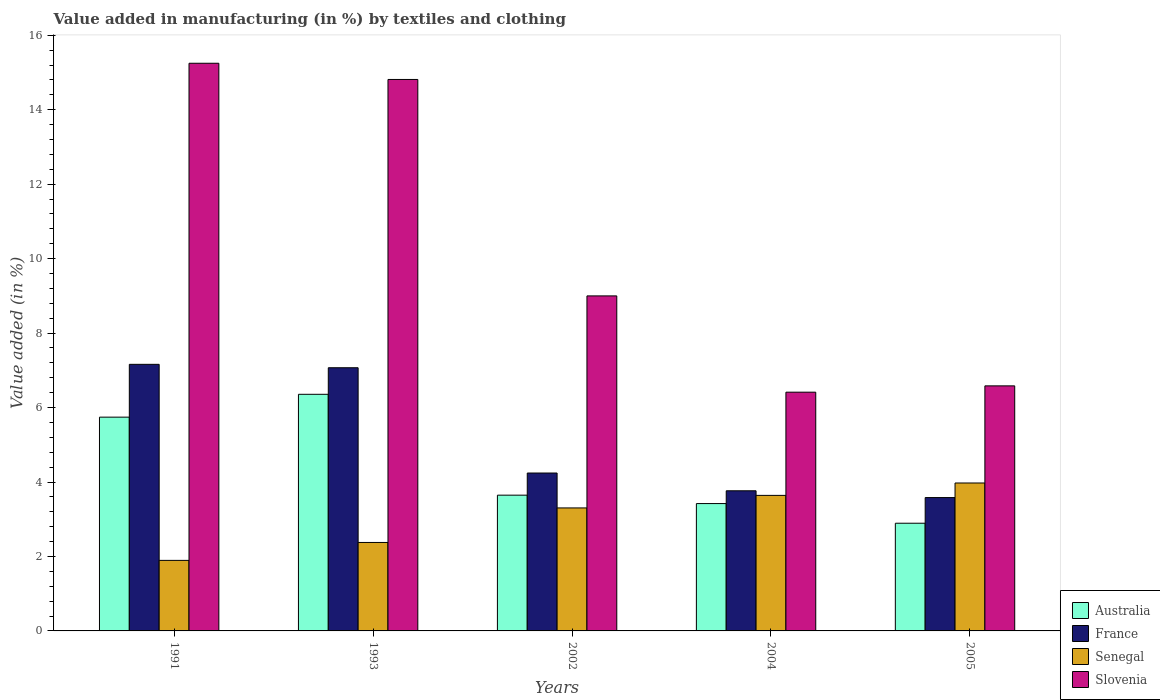Are the number of bars per tick equal to the number of legend labels?
Keep it short and to the point. Yes. Are the number of bars on each tick of the X-axis equal?
Offer a very short reply. Yes. What is the label of the 5th group of bars from the left?
Provide a succinct answer. 2005. In how many cases, is the number of bars for a given year not equal to the number of legend labels?
Give a very brief answer. 0. What is the percentage of value added in manufacturing by textiles and clothing in Senegal in 2004?
Ensure brevity in your answer.  3.64. Across all years, what is the maximum percentage of value added in manufacturing by textiles and clothing in Slovenia?
Ensure brevity in your answer.  15.25. Across all years, what is the minimum percentage of value added in manufacturing by textiles and clothing in Slovenia?
Provide a succinct answer. 6.41. In which year was the percentage of value added in manufacturing by textiles and clothing in Senegal maximum?
Provide a short and direct response. 2005. What is the total percentage of value added in manufacturing by textiles and clothing in Senegal in the graph?
Provide a short and direct response. 15.19. What is the difference between the percentage of value added in manufacturing by textiles and clothing in Senegal in 1991 and that in 1993?
Keep it short and to the point. -0.48. What is the difference between the percentage of value added in manufacturing by textiles and clothing in Slovenia in 1993 and the percentage of value added in manufacturing by textiles and clothing in Australia in 2005?
Your response must be concise. 11.92. What is the average percentage of value added in manufacturing by textiles and clothing in Australia per year?
Ensure brevity in your answer.  4.41. In the year 2004, what is the difference between the percentage of value added in manufacturing by textiles and clothing in France and percentage of value added in manufacturing by textiles and clothing in Slovenia?
Your response must be concise. -2.65. What is the ratio of the percentage of value added in manufacturing by textiles and clothing in Australia in 2004 to that in 2005?
Your response must be concise. 1.18. Is the difference between the percentage of value added in manufacturing by textiles and clothing in France in 1991 and 2002 greater than the difference between the percentage of value added in manufacturing by textiles and clothing in Slovenia in 1991 and 2002?
Ensure brevity in your answer.  No. What is the difference between the highest and the second highest percentage of value added in manufacturing by textiles and clothing in France?
Offer a very short reply. 0.09. What is the difference between the highest and the lowest percentage of value added in manufacturing by textiles and clothing in Senegal?
Your answer should be compact. 2.08. Is it the case that in every year, the sum of the percentage of value added in manufacturing by textiles and clothing in Slovenia and percentage of value added in manufacturing by textiles and clothing in France is greater than the sum of percentage of value added in manufacturing by textiles and clothing in Senegal and percentage of value added in manufacturing by textiles and clothing in Australia?
Provide a short and direct response. No. What does the 1st bar from the right in 1993 represents?
Make the answer very short. Slovenia. How many bars are there?
Make the answer very short. 20. Are the values on the major ticks of Y-axis written in scientific E-notation?
Your answer should be very brief. No. Does the graph contain any zero values?
Your response must be concise. No. What is the title of the graph?
Provide a short and direct response. Value added in manufacturing (in %) by textiles and clothing. What is the label or title of the Y-axis?
Provide a short and direct response. Value added (in %). What is the Value added (in %) of Australia in 1991?
Make the answer very short. 5.74. What is the Value added (in %) of France in 1991?
Ensure brevity in your answer.  7.16. What is the Value added (in %) of Senegal in 1991?
Offer a very short reply. 1.89. What is the Value added (in %) of Slovenia in 1991?
Your answer should be very brief. 15.25. What is the Value added (in %) in Australia in 1993?
Offer a terse response. 6.36. What is the Value added (in %) of France in 1993?
Keep it short and to the point. 7.07. What is the Value added (in %) in Senegal in 1993?
Offer a terse response. 2.38. What is the Value added (in %) of Slovenia in 1993?
Provide a short and direct response. 14.81. What is the Value added (in %) in Australia in 2002?
Ensure brevity in your answer.  3.65. What is the Value added (in %) of France in 2002?
Keep it short and to the point. 4.24. What is the Value added (in %) in Senegal in 2002?
Your response must be concise. 3.3. What is the Value added (in %) in Slovenia in 2002?
Offer a terse response. 9. What is the Value added (in %) of Australia in 2004?
Provide a succinct answer. 3.42. What is the Value added (in %) in France in 2004?
Give a very brief answer. 3.76. What is the Value added (in %) in Senegal in 2004?
Your answer should be compact. 3.64. What is the Value added (in %) in Slovenia in 2004?
Your response must be concise. 6.41. What is the Value added (in %) in Australia in 2005?
Give a very brief answer. 2.89. What is the Value added (in %) in France in 2005?
Make the answer very short. 3.58. What is the Value added (in %) of Senegal in 2005?
Offer a very short reply. 3.97. What is the Value added (in %) in Slovenia in 2005?
Give a very brief answer. 6.58. Across all years, what is the maximum Value added (in %) of Australia?
Ensure brevity in your answer.  6.36. Across all years, what is the maximum Value added (in %) in France?
Your answer should be compact. 7.16. Across all years, what is the maximum Value added (in %) in Senegal?
Your answer should be compact. 3.97. Across all years, what is the maximum Value added (in %) in Slovenia?
Your answer should be compact. 15.25. Across all years, what is the minimum Value added (in %) in Australia?
Give a very brief answer. 2.89. Across all years, what is the minimum Value added (in %) of France?
Offer a very short reply. 3.58. Across all years, what is the minimum Value added (in %) in Senegal?
Provide a succinct answer. 1.89. Across all years, what is the minimum Value added (in %) of Slovenia?
Offer a terse response. 6.41. What is the total Value added (in %) of Australia in the graph?
Offer a very short reply. 22.06. What is the total Value added (in %) in France in the graph?
Offer a very short reply. 25.82. What is the total Value added (in %) in Senegal in the graph?
Your answer should be very brief. 15.19. What is the total Value added (in %) of Slovenia in the graph?
Offer a very short reply. 52.06. What is the difference between the Value added (in %) of Australia in 1991 and that in 1993?
Make the answer very short. -0.61. What is the difference between the Value added (in %) in France in 1991 and that in 1993?
Your answer should be very brief. 0.09. What is the difference between the Value added (in %) of Senegal in 1991 and that in 1993?
Give a very brief answer. -0.48. What is the difference between the Value added (in %) of Slovenia in 1991 and that in 1993?
Your answer should be compact. 0.44. What is the difference between the Value added (in %) of Australia in 1991 and that in 2002?
Your answer should be compact. 2.1. What is the difference between the Value added (in %) in France in 1991 and that in 2002?
Offer a terse response. 2.92. What is the difference between the Value added (in %) in Senegal in 1991 and that in 2002?
Offer a terse response. -1.41. What is the difference between the Value added (in %) in Slovenia in 1991 and that in 2002?
Make the answer very short. 6.25. What is the difference between the Value added (in %) of Australia in 1991 and that in 2004?
Offer a very short reply. 2.32. What is the difference between the Value added (in %) of France in 1991 and that in 2004?
Ensure brevity in your answer.  3.4. What is the difference between the Value added (in %) of Senegal in 1991 and that in 2004?
Keep it short and to the point. -1.75. What is the difference between the Value added (in %) of Slovenia in 1991 and that in 2004?
Keep it short and to the point. 8.84. What is the difference between the Value added (in %) in Australia in 1991 and that in 2005?
Provide a short and direct response. 2.85. What is the difference between the Value added (in %) of France in 1991 and that in 2005?
Keep it short and to the point. 3.58. What is the difference between the Value added (in %) in Senegal in 1991 and that in 2005?
Offer a very short reply. -2.08. What is the difference between the Value added (in %) in Slovenia in 1991 and that in 2005?
Ensure brevity in your answer.  8.67. What is the difference between the Value added (in %) of Australia in 1993 and that in 2002?
Your answer should be very brief. 2.71. What is the difference between the Value added (in %) in France in 1993 and that in 2002?
Keep it short and to the point. 2.83. What is the difference between the Value added (in %) of Senegal in 1993 and that in 2002?
Provide a short and direct response. -0.93. What is the difference between the Value added (in %) in Slovenia in 1993 and that in 2002?
Give a very brief answer. 5.81. What is the difference between the Value added (in %) of Australia in 1993 and that in 2004?
Offer a terse response. 2.94. What is the difference between the Value added (in %) in France in 1993 and that in 2004?
Provide a succinct answer. 3.31. What is the difference between the Value added (in %) in Senegal in 1993 and that in 2004?
Give a very brief answer. -1.26. What is the difference between the Value added (in %) in Slovenia in 1993 and that in 2004?
Offer a very short reply. 8.4. What is the difference between the Value added (in %) in Australia in 1993 and that in 2005?
Provide a short and direct response. 3.46. What is the difference between the Value added (in %) in France in 1993 and that in 2005?
Ensure brevity in your answer.  3.49. What is the difference between the Value added (in %) of Senegal in 1993 and that in 2005?
Provide a short and direct response. -1.6. What is the difference between the Value added (in %) of Slovenia in 1993 and that in 2005?
Make the answer very short. 8.23. What is the difference between the Value added (in %) of Australia in 2002 and that in 2004?
Provide a succinct answer. 0.23. What is the difference between the Value added (in %) of France in 2002 and that in 2004?
Provide a succinct answer. 0.48. What is the difference between the Value added (in %) of Senegal in 2002 and that in 2004?
Keep it short and to the point. -0.34. What is the difference between the Value added (in %) in Slovenia in 2002 and that in 2004?
Offer a terse response. 2.59. What is the difference between the Value added (in %) of Australia in 2002 and that in 2005?
Your answer should be very brief. 0.75. What is the difference between the Value added (in %) in France in 2002 and that in 2005?
Offer a terse response. 0.66. What is the difference between the Value added (in %) of Senegal in 2002 and that in 2005?
Offer a very short reply. -0.67. What is the difference between the Value added (in %) in Slovenia in 2002 and that in 2005?
Provide a short and direct response. 2.42. What is the difference between the Value added (in %) of Australia in 2004 and that in 2005?
Make the answer very short. 0.53. What is the difference between the Value added (in %) in France in 2004 and that in 2005?
Ensure brevity in your answer.  0.18. What is the difference between the Value added (in %) in Senegal in 2004 and that in 2005?
Keep it short and to the point. -0.33. What is the difference between the Value added (in %) in Slovenia in 2004 and that in 2005?
Your answer should be compact. -0.17. What is the difference between the Value added (in %) in Australia in 1991 and the Value added (in %) in France in 1993?
Keep it short and to the point. -1.33. What is the difference between the Value added (in %) of Australia in 1991 and the Value added (in %) of Senegal in 1993?
Your answer should be compact. 3.37. What is the difference between the Value added (in %) in Australia in 1991 and the Value added (in %) in Slovenia in 1993?
Your answer should be very brief. -9.07. What is the difference between the Value added (in %) of France in 1991 and the Value added (in %) of Senegal in 1993?
Ensure brevity in your answer.  4.78. What is the difference between the Value added (in %) of France in 1991 and the Value added (in %) of Slovenia in 1993?
Give a very brief answer. -7.65. What is the difference between the Value added (in %) in Senegal in 1991 and the Value added (in %) in Slovenia in 1993?
Keep it short and to the point. -12.92. What is the difference between the Value added (in %) in Australia in 1991 and the Value added (in %) in France in 2002?
Your response must be concise. 1.5. What is the difference between the Value added (in %) in Australia in 1991 and the Value added (in %) in Senegal in 2002?
Make the answer very short. 2.44. What is the difference between the Value added (in %) of Australia in 1991 and the Value added (in %) of Slovenia in 2002?
Provide a short and direct response. -3.26. What is the difference between the Value added (in %) of France in 1991 and the Value added (in %) of Senegal in 2002?
Provide a succinct answer. 3.86. What is the difference between the Value added (in %) in France in 1991 and the Value added (in %) in Slovenia in 2002?
Your answer should be compact. -1.84. What is the difference between the Value added (in %) of Senegal in 1991 and the Value added (in %) of Slovenia in 2002?
Ensure brevity in your answer.  -7.1. What is the difference between the Value added (in %) of Australia in 1991 and the Value added (in %) of France in 2004?
Provide a short and direct response. 1.98. What is the difference between the Value added (in %) of Australia in 1991 and the Value added (in %) of Senegal in 2004?
Offer a very short reply. 2.1. What is the difference between the Value added (in %) in Australia in 1991 and the Value added (in %) in Slovenia in 2004?
Offer a terse response. -0.67. What is the difference between the Value added (in %) of France in 1991 and the Value added (in %) of Senegal in 2004?
Your answer should be very brief. 3.52. What is the difference between the Value added (in %) of France in 1991 and the Value added (in %) of Slovenia in 2004?
Your answer should be compact. 0.75. What is the difference between the Value added (in %) in Senegal in 1991 and the Value added (in %) in Slovenia in 2004?
Keep it short and to the point. -4.52. What is the difference between the Value added (in %) in Australia in 1991 and the Value added (in %) in France in 2005?
Your response must be concise. 2.16. What is the difference between the Value added (in %) of Australia in 1991 and the Value added (in %) of Senegal in 2005?
Provide a short and direct response. 1.77. What is the difference between the Value added (in %) of Australia in 1991 and the Value added (in %) of Slovenia in 2005?
Offer a very short reply. -0.84. What is the difference between the Value added (in %) of France in 1991 and the Value added (in %) of Senegal in 2005?
Your response must be concise. 3.19. What is the difference between the Value added (in %) in France in 1991 and the Value added (in %) in Slovenia in 2005?
Your response must be concise. 0.58. What is the difference between the Value added (in %) in Senegal in 1991 and the Value added (in %) in Slovenia in 2005?
Provide a short and direct response. -4.69. What is the difference between the Value added (in %) of Australia in 1993 and the Value added (in %) of France in 2002?
Your answer should be very brief. 2.11. What is the difference between the Value added (in %) in Australia in 1993 and the Value added (in %) in Senegal in 2002?
Provide a succinct answer. 3.05. What is the difference between the Value added (in %) of Australia in 1993 and the Value added (in %) of Slovenia in 2002?
Give a very brief answer. -2.64. What is the difference between the Value added (in %) of France in 1993 and the Value added (in %) of Senegal in 2002?
Ensure brevity in your answer.  3.77. What is the difference between the Value added (in %) of France in 1993 and the Value added (in %) of Slovenia in 2002?
Make the answer very short. -1.93. What is the difference between the Value added (in %) of Senegal in 1993 and the Value added (in %) of Slovenia in 2002?
Your response must be concise. -6.62. What is the difference between the Value added (in %) of Australia in 1993 and the Value added (in %) of France in 2004?
Ensure brevity in your answer.  2.59. What is the difference between the Value added (in %) in Australia in 1993 and the Value added (in %) in Senegal in 2004?
Offer a very short reply. 2.71. What is the difference between the Value added (in %) in Australia in 1993 and the Value added (in %) in Slovenia in 2004?
Give a very brief answer. -0.06. What is the difference between the Value added (in %) of France in 1993 and the Value added (in %) of Senegal in 2004?
Offer a terse response. 3.43. What is the difference between the Value added (in %) in France in 1993 and the Value added (in %) in Slovenia in 2004?
Your response must be concise. 0.66. What is the difference between the Value added (in %) in Senegal in 1993 and the Value added (in %) in Slovenia in 2004?
Provide a succinct answer. -4.04. What is the difference between the Value added (in %) in Australia in 1993 and the Value added (in %) in France in 2005?
Offer a terse response. 2.77. What is the difference between the Value added (in %) in Australia in 1993 and the Value added (in %) in Senegal in 2005?
Keep it short and to the point. 2.38. What is the difference between the Value added (in %) of Australia in 1993 and the Value added (in %) of Slovenia in 2005?
Provide a succinct answer. -0.23. What is the difference between the Value added (in %) in France in 1993 and the Value added (in %) in Senegal in 2005?
Your answer should be very brief. 3.1. What is the difference between the Value added (in %) in France in 1993 and the Value added (in %) in Slovenia in 2005?
Ensure brevity in your answer.  0.49. What is the difference between the Value added (in %) in Senegal in 1993 and the Value added (in %) in Slovenia in 2005?
Keep it short and to the point. -4.21. What is the difference between the Value added (in %) in Australia in 2002 and the Value added (in %) in France in 2004?
Offer a terse response. -0.12. What is the difference between the Value added (in %) of Australia in 2002 and the Value added (in %) of Senegal in 2004?
Offer a very short reply. 0.01. What is the difference between the Value added (in %) of Australia in 2002 and the Value added (in %) of Slovenia in 2004?
Ensure brevity in your answer.  -2.77. What is the difference between the Value added (in %) of France in 2002 and the Value added (in %) of Senegal in 2004?
Offer a very short reply. 0.6. What is the difference between the Value added (in %) in France in 2002 and the Value added (in %) in Slovenia in 2004?
Give a very brief answer. -2.17. What is the difference between the Value added (in %) in Senegal in 2002 and the Value added (in %) in Slovenia in 2004?
Give a very brief answer. -3.11. What is the difference between the Value added (in %) in Australia in 2002 and the Value added (in %) in France in 2005?
Offer a very short reply. 0.06. What is the difference between the Value added (in %) of Australia in 2002 and the Value added (in %) of Senegal in 2005?
Provide a short and direct response. -0.33. What is the difference between the Value added (in %) of Australia in 2002 and the Value added (in %) of Slovenia in 2005?
Ensure brevity in your answer.  -2.94. What is the difference between the Value added (in %) in France in 2002 and the Value added (in %) in Senegal in 2005?
Provide a succinct answer. 0.27. What is the difference between the Value added (in %) in France in 2002 and the Value added (in %) in Slovenia in 2005?
Your answer should be compact. -2.34. What is the difference between the Value added (in %) of Senegal in 2002 and the Value added (in %) of Slovenia in 2005?
Your answer should be very brief. -3.28. What is the difference between the Value added (in %) of Australia in 2004 and the Value added (in %) of France in 2005?
Offer a terse response. -0.16. What is the difference between the Value added (in %) of Australia in 2004 and the Value added (in %) of Senegal in 2005?
Make the answer very short. -0.55. What is the difference between the Value added (in %) in Australia in 2004 and the Value added (in %) in Slovenia in 2005?
Make the answer very short. -3.16. What is the difference between the Value added (in %) in France in 2004 and the Value added (in %) in Senegal in 2005?
Provide a succinct answer. -0.21. What is the difference between the Value added (in %) of France in 2004 and the Value added (in %) of Slovenia in 2005?
Offer a terse response. -2.82. What is the difference between the Value added (in %) of Senegal in 2004 and the Value added (in %) of Slovenia in 2005?
Offer a very short reply. -2.94. What is the average Value added (in %) of Australia per year?
Ensure brevity in your answer.  4.41. What is the average Value added (in %) of France per year?
Offer a very short reply. 5.16. What is the average Value added (in %) in Senegal per year?
Offer a very short reply. 3.04. What is the average Value added (in %) in Slovenia per year?
Provide a succinct answer. 10.41. In the year 1991, what is the difference between the Value added (in %) of Australia and Value added (in %) of France?
Ensure brevity in your answer.  -1.42. In the year 1991, what is the difference between the Value added (in %) in Australia and Value added (in %) in Senegal?
Give a very brief answer. 3.85. In the year 1991, what is the difference between the Value added (in %) of Australia and Value added (in %) of Slovenia?
Keep it short and to the point. -9.51. In the year 1991, what is the difference between the Value added (in %) in France and Value added (in %) in Senegal?
Your answer should be very brief. 5.27. In the year 1991, what is the difference between the Value added (in %) in France and Value added (in %) in Slovenia?
Offer a very short reply. -8.09. In the year 1991, what is the difference between the Value added (in %) in Senegal and Value added (in %) in Slovenia?
Keep it short and to the point. -13.35. In the year 1993, what is the difference between the Value added (in %) of Australia and Value added (in %) of France?
Offer a very short reply. -0.71. In the year 1993, what is the difference between the Value added (in %) in Australia and Value added (in %) in Senegal?
Your answer should be very brief. 3.98. In the year 1993, what is the difference between the Value added (in %) of Australia and Value added (in %) of Slovenia?
Ensure brevity in your answer.  -8.46. In the year 1993, what is the difference between the Value added (in %) in France and Value added (in %) in Senegal?
Make the answer very short. 4.69. In the year 1993, what is the difference between the Value added (in %) in France and Value added (in %) in Slovenia?
Keep it short and to the point. -7.74. In the year 1993, what is the difference between the Value added (in %) of Senegal and Value added (in %) of Slovenia?
Offer a very short reply. -12.44. In the year 2002, what is the difference between the Value added (in %) in Australia and Value added (in %) in France?
Keep it short and to the point. -0.59. In the year 2002, what is the difference between the Value added (in %) in Australia and Value added (in %) in Senegal?
Offer a very short reply. 0.34. In the year 2002, what is the difference between the Value added (in %) in Australia and Value added (in %) in Slovenia?
Provide a succinct answer. -5.35. In the year 2002, what is the difference between the Value added (in %) of France and Value added (in %) of Senegal?
Your answer should be very brief. 0.94. In the year 2002, what is the difference between the Value added (in %) in France and Value added (in %) in Slovenia?
Give a very brief answer. -4.76. In the year 2002, what is the difference between the Value added (in %) of Senegal and Value added (in %) of Slovenia?
Provide a short and direct response. -5.7. In the year 2004, what is the difference between the Value added (in %) of Australia and Value added (in %) of France?
Your answer should be compact. -0.34. In the year 2004, what is the difference between the Value added (in %) in Australia and Value added (in %) in Senegal?
Your answer should be very brief. -0.22. In the year 2004, what is the difference between the Value added (in %) in Australia and Value added (in %) in Slovenia?
Your answer should be compact. -2.99. In the year 2004, what is the difference between the Value added (in %) of France and Value added (in %) of Senegal?
Offer a terse response. 0.12. In the year 2004, what is the difference between the Value added (in %) in France and Value added (in %) in Slovenia?
Make the answer very short. -2.65. In the year 2004, what is the difference between the Value added (in %) of Senegal and Value added (in %) of Slovenia?
Make the answer very short. -2.77. In the year 2005, what is the difference between the Value added (in %) in Australia and Value added (in %) in France?
Offer a very short reply. -0.69. In the year 2005, what is the difference between the Value added (in %) of Australia and Value added (in %) of Senegal?
Your answer should be very brief. -1.08. In the year 2005, what is the difference between the Value added (in %) in Australia and Value added (in %) in Slovenia?
Give a very brief answer. -3.69. In the year 2005, what is the difference between the Value added (in %) in France and Value added (in %) in Senegal?
Your answer should be very brief. -0.39. In the year 2005, what is the difference between the Value added (in %) in France and Value added (in %) in Slovenia?
Offer a terse response. -3. In the year 2005, what is the difference between the Value added (in %) of Senegal and Value added (in %) of Slovenia?
Give a very brief answer. -2.61. What is the ratio of the Value added (in %) in Australia in 1991 to that in 1993?
Provide a succinct answer. 0.9. What is the ratio of the Value added (in %) in France in 1991 to that in 1993?
Give a very brief answer. 1.01. What is the ratio of the Value added (in %) in Senegal in 1991 to that in 1993?
Give a very brief answer. 0.8. What is the ratio of the Value added (in %) in Slovenia in 1991 to that in 1993?
Offer a very short reply. 1.03. What is the ratio of the Value added (in %) of Australia in 1991 to that in 2002?
Ensure brevity in your answer.  1.57. What is the ratio of the Value added (in %) of France in 1991 to that in 2002?
Make the answer very short. 1.69. What is the ratio of the Value added (in %) of Senegal in 1991 to that in 2002?
Give a very brief answer. 0.57. What is the ratio of the Value added (in %) in Slovenia in 1991 to that in 2002?
Keep it short and to the point. 1.69. What is the ratio of the Value added (in %) in Australia in 1991 to that in 2004?
Give a very brief answer. 1.68. What is the ratio of the Value added (in %) of France in 1991 to that in 2004?
Your answer should be very brief. 1.9. What is the ratio of the Value added (in %) of Senegal in 1991 to that in 2004?
Make the answer very short. 0.52. What is the ratio of the Value added (in %) of Slovenia in 1991 to that in 2004?
Your response must be concise. 2.38. What is the ratio of the Value added (in %) in Australia in 1991 to that in 2005?
Give a very brief answer. 1.99. What is the ratio of the Value added (in %) in France in 1991 to that in 2005?
Your answer should be very brief. 2. What is the ratio of the Value added (in %) of Senegal in 1991 to that in 2005?
Make the answer very short. 0.48. What is the ratio of the Value added (in %) in Slovenia in 1991 to that in 2005?
Provide a succinct answer. 2.32. What is the ratio of the Value added (in %) of Australia in 1993 to that in 2002?
Your response must be concise. 1.74. What is the ratio of the Value added (in %) in Senegal in 1993 to that in 2002?
Your answer should be compact. 0.72. What is the ratio of the Value added (in %) of Slovenia in 1993 to that in 2002?
Ensure brevity in your answer.  1.65. What is the ratio of the Value added (in %) in Australia in 1993 to that in 2004?
Keep it short and to the point. 1.86. What is the ratio of the Value added (in %) of France in 1993 to that in 2004?
Offer a very short reply. 1.88. What is the ratio of the Value added (in %) of Senegal in 1993 to that in 2004?
Give a very brief answer. 0.65. What is the ratio of the Value added (in %) in Slovenia in 1993 to that in 2004?
Make the answer very short. 2.31. What is the ratio of the Value added (in %) in Australia in 1993 to that in 2005?
Make the answer very short. 2.2. What is the ratio of the Value added (in %) of France in 1993 to that in 2005?
Your answer should be very brief. 1.97. What is the ratio of the Value added (in %) in Senegal in 1993 to that in 2005?
Offer a very short reply. 0.6. What is the ratio of the Value added (in %) in Slovenia in 1993 to that in 2005?
Your answer should be compact. 2.25. What is the ratio of the Value added (in %) of Australia in 2002 to that in 2004?
Your answer should be very brief. 1.07. What is the ratio of the Value added (in %) of France in 2002 to that in 2004?
Offer a very short reply. 1.13. What is the ratio of the Value added (in %) in Senegal in 2002 to that in 2004?
Offer a very short reply. 0.91. What is the ratio of the Value added (in %) in Slovenia in 2002 to that in 2004?
Provide a short and direct response. 1.4. What is the ratio of the Value added (in %) in Australia in 2002 to that in 2005?
Offer a terse response. 1.26. What is the ratio of the Value added (in %) in France in 2002 to that in 2005?
Ensure brevity in your answer.  1.18. What is the ratio of the Value added (in %) of Senegal in 2002 to that in 2005?
Offer a very short reply. 0.83. What is the ratio of the Value added (in %) of Slovenia in 2002 to that in 2005?
Ensure brevity in your answer.  1.37. What is the ratio of the Value added (in %) of Australia in 2004 to that in 2005?
Provide a succinct answer. 1.18. What is the ratio of the Value added (in %) of France in 2004 to that in 2005?
Offer a very short reply. 1.05. What is the ratio of the Value added (in %) of Senegal in 2004 to that in 2005?
Provide a short and direct response. 0.92. What is the ratio of the Value added (in %) in Slovenia in 2004 to that in 2005?
Provide a succinct answer. 0.97. What is the difference between the highest and the second highest Value added (in %) in Australia?
Your response must be concise. 0.61. What is the difference between the highest and the second highest Value added (in %) of France?
Your answer should be compact. 0.09. What is the difference between the highest and the second highest Value added (in %) in Senegal?
Your response must be concise. 0.33. What is the difference between the highest and the second highest Value added (in %) in Slovenia?
Make the answer very short. 0.44. What is the difference between the highest and the lowest Value added (in %) of Australia?
Your answer should be compact. 3.46. What is the difference between the highest and the lowest Value added (in %) in France?
Ensure brevity in your answer.  3.58. What is the difference between the highest and the lowest Value added (in %) in Senegal?
Ensure brevity in your answer.  2.08. What is the difference between the highest and the lowest Value added (in %) in Slovenia?
Keep it short and to the point. 8.84. 